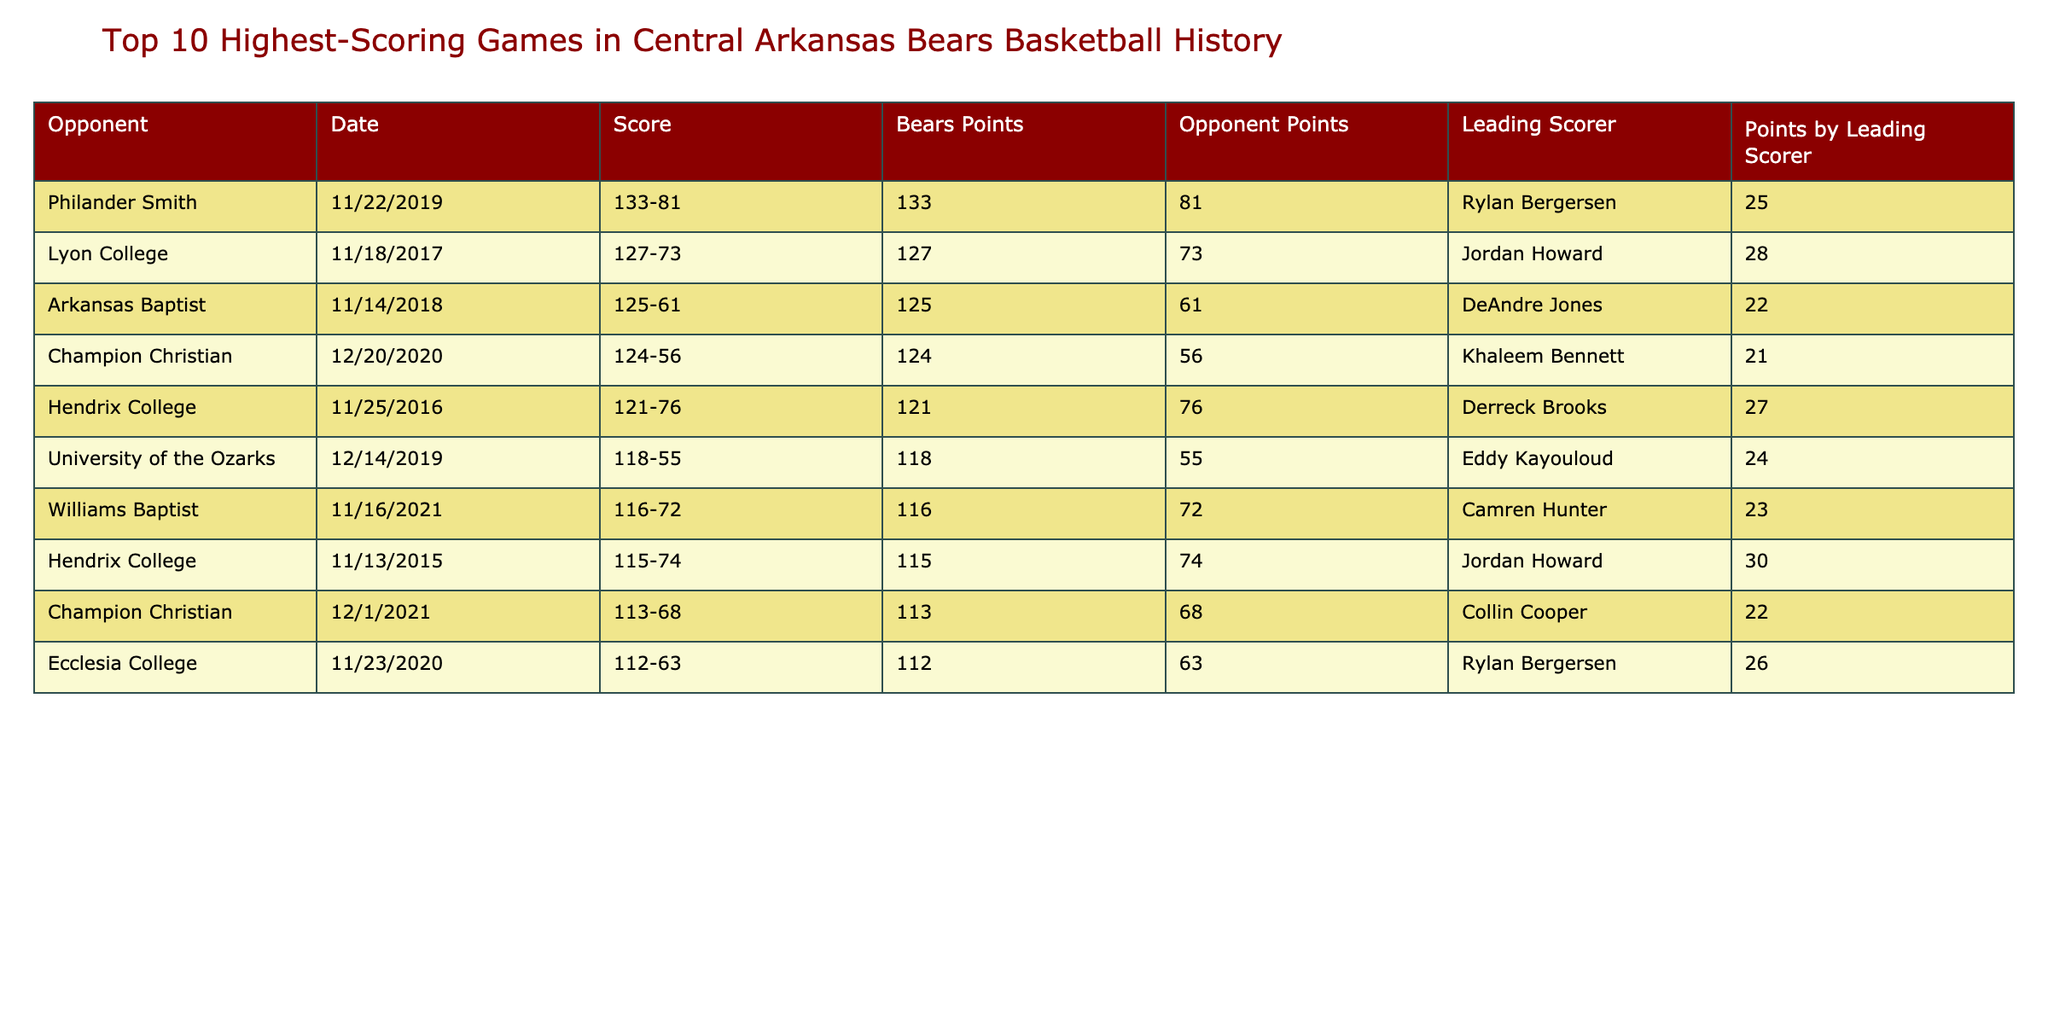What was the highest score by the Central Arkansas Bears in a single game? The highest score in the table is 133 points, achieved against Philander Smith on 11/22/2019.
Answer: 133 Who was the leading scorer in the game with the highest score? The leading scorer for the Central Arkansas Bears in the highest-scoring game (133 points against Philander Smith) was Rylan Bergersen, with 25 points.
Answer: Rylan Bergersen How many points did the Central Arkansas Bears score against Hendrix College on 11/25/2016? The score for the game against Hendrix College on 11/25/2016 was 121 points.
Answer: 121 Which opponent had the closest score to the Bears on the lowest scoring game in the top 10? The lowest score in the top 10 is 112 points against Ecclesia College, who scored 63 points. The difference is the largest among all games in this list, meaning there was a significant gap in scores.
Answer: Ecclesia College What is the average score of the Central Arkansas Bears in the top 10 highest-scoring games? To find the average, we sum the Bears' points (133, 127, 125, 124, 121, 118, 116, 115, 113, 112) to get 1,223, and divide by 10, yielding an average of 122.3.
Answer: 122.3 Did the Central Arkansas Bears score more than 120 points in all of their top 10 highest-scoring games? No, the Bears scored below 120 points in the games against Hendrix College (115 points) and Champion Christian (113 points), which indicates they did not exceed 120 in every game listed.
Answer: No Which game had the highest margin of victory, and what was that margin? The game against Philander Smith had the highest margin of victory, scoring 133 while allowing 81, resulting in a margin of 52 points (133 - 81).
Answer: 52 How many points did the leading scorer score in the game against Williams Baptist? In the game against Williams Baptist on 11/16/2021, the leading scorer, Camren Hunter, scored 23 points.
Answer: 23 What percentage of the total points scored by the Central Arkansas Bears was from the leading scorer in their game against Lyon College? In the game against Lyon College, the Bears scored 127 points, and the leading scorer, Jordan Howard, scored 28 points. The percentage calculated is (28/127)*100 ≈ 22.05%.
Answer: 22.05% In how many games did the Central Arkansas Bears score over 120 points? Upon reviewing the table, the Bears scored over 120 points in 6 games: 133, 127, 125, 124, 121, and 118.
Answer: 6 Which two opponents did the Bears play within a week of each other in November 2021? The Bears played Hendrix College on 11/13/2015 and Williams Baptist on 11/16/2021, falling within a week in a similar time frame in November.
Answer: Hendrix College and Williams Baptist 